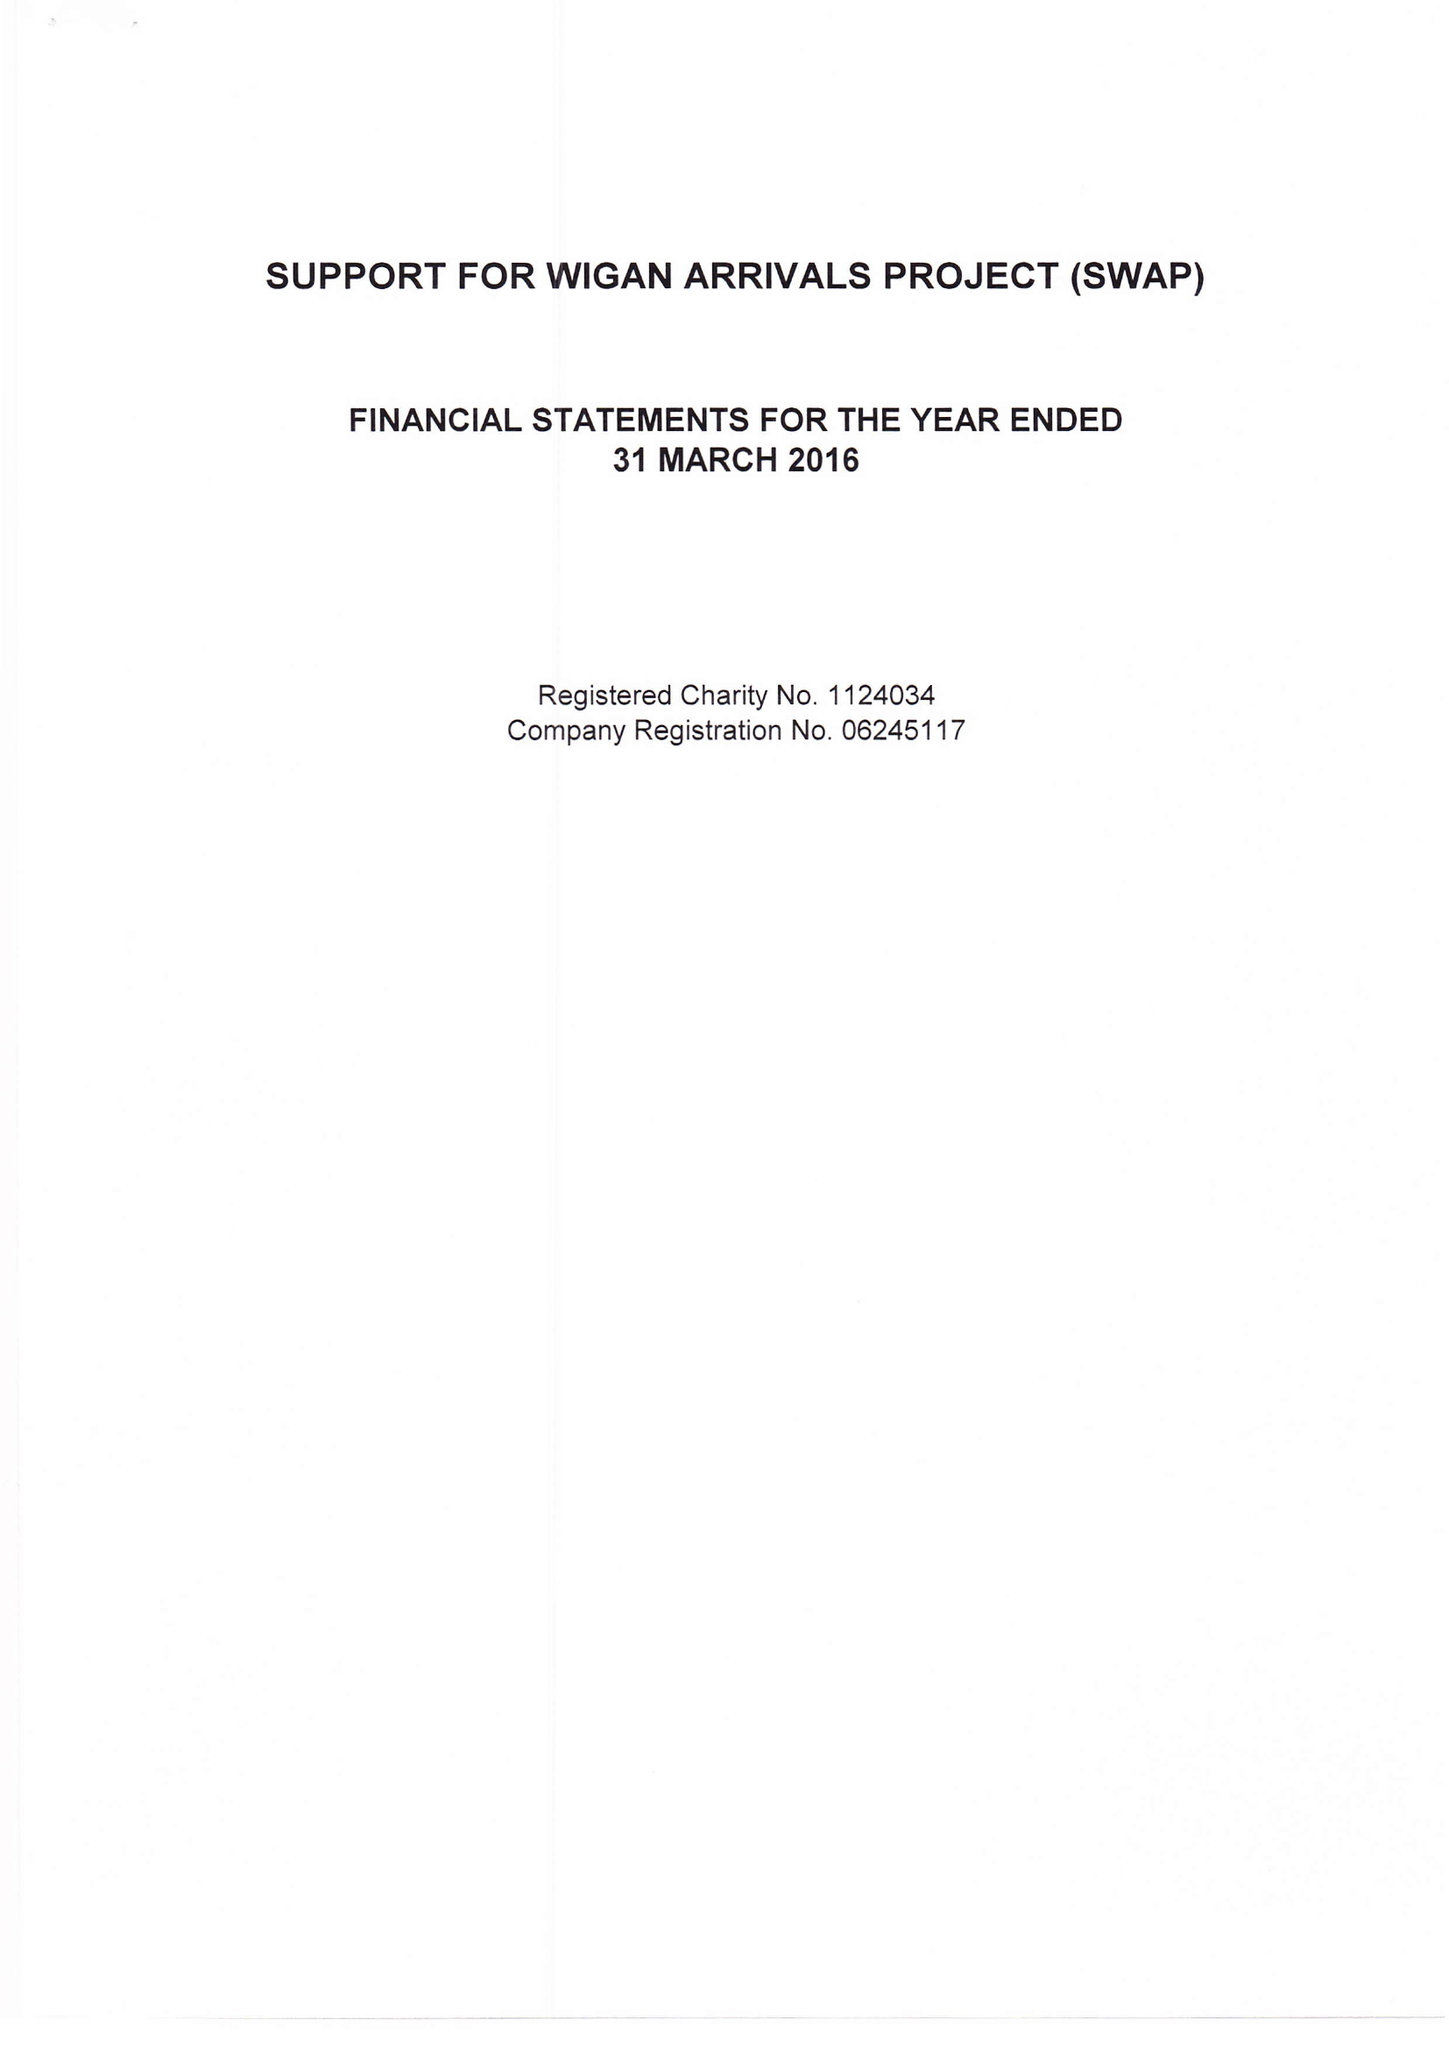What is the value for the report_date?
Answer the question using a single word or phrase. 2016-03-31 